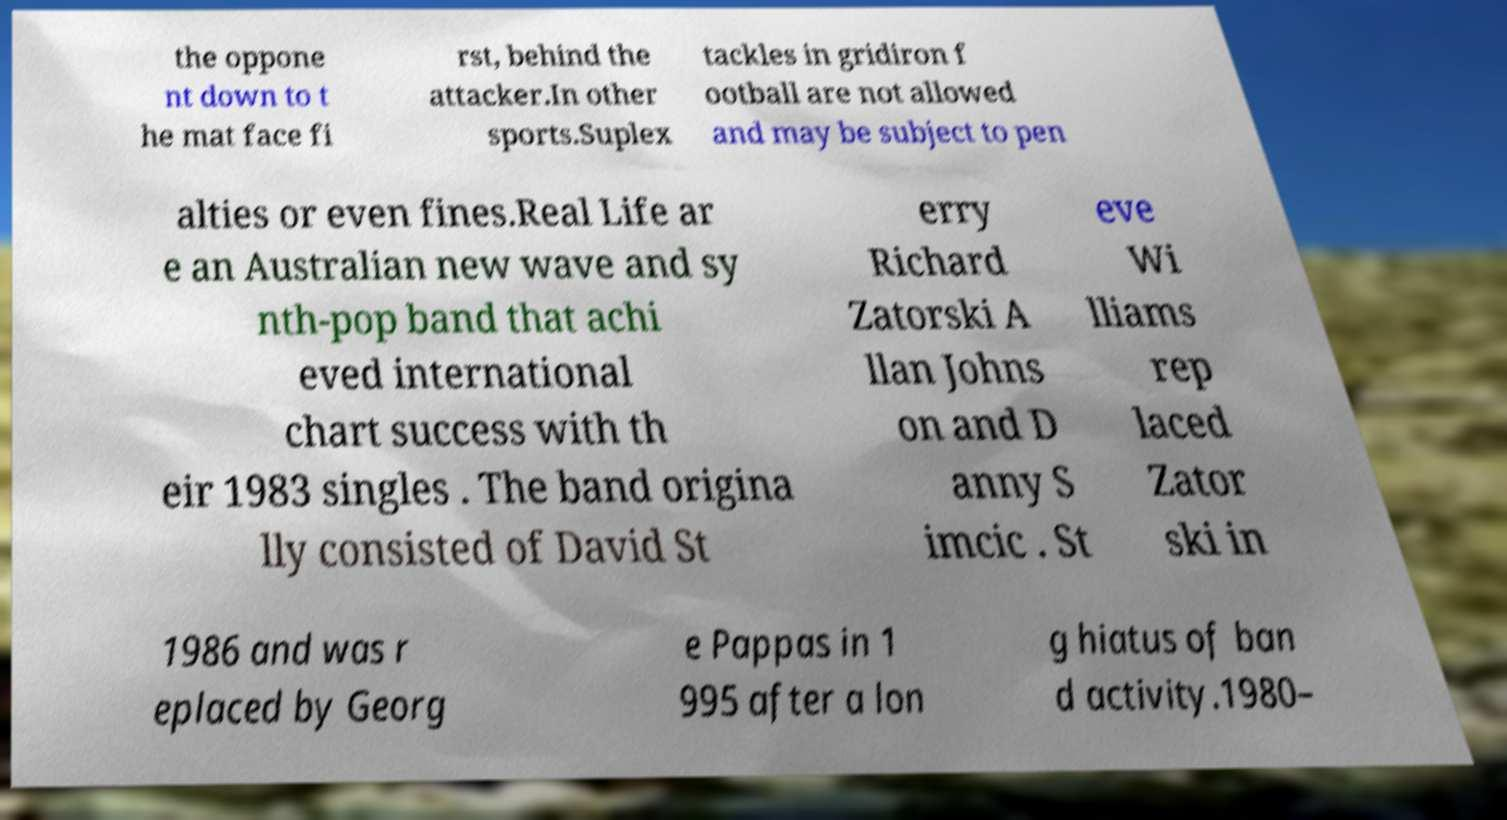I need the written content from this picture converted into text. Can you do that? the oppone nt down to t he mat face fi rst, behind the attacker.In other sports.Suplex tackles in gridiron f ootball are not allowed and may be subject to pen alties or even fines.Real Life ar e an Australian new wave and sy nth-pop band that achi eved international chart success with th eir 1983 singles . The band origina lly consisted of David St erry Richard Zatorski A llan Johns on and D anny S imcic . St eve Wi lliams rep laced Zator ski in 1986 and was r eplaced by Georg e Pappas in 1 995 after a lon g hiatus of ban d activity.1980– 